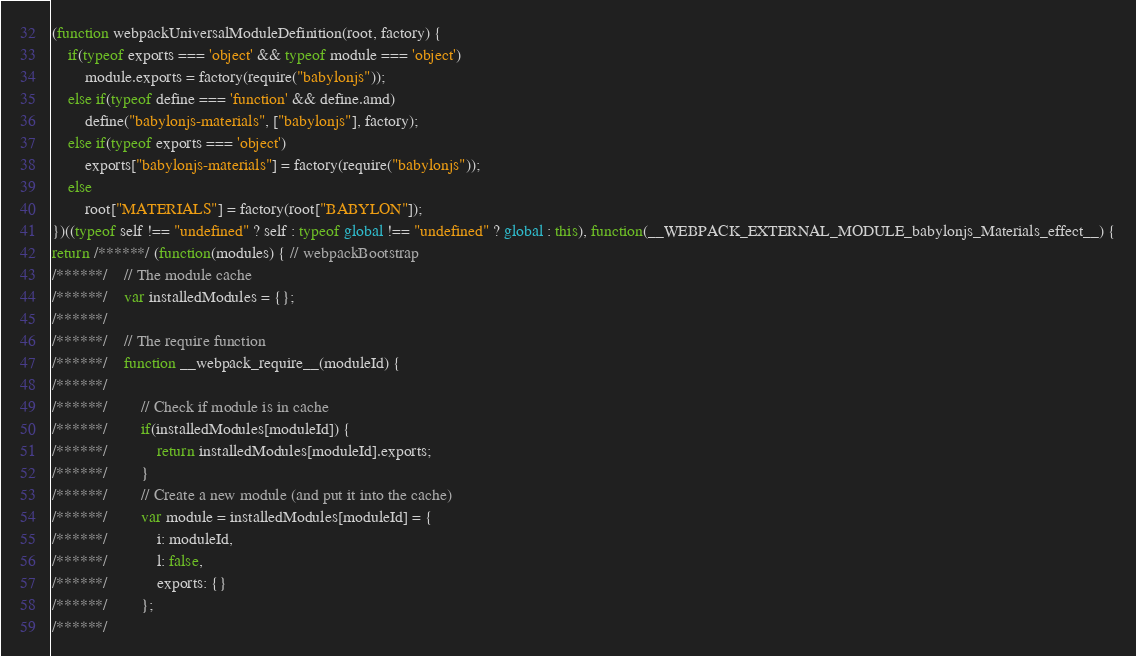<code> <loc_0><loc_0><loc_500><loc_500><_JavaScript_>(function webpackUniversalModuleDefinition(root, factory) {
	if(typeof exports === 'object' && typeof module === 'object')
		module.exports = factory(require("babylonjs"));
	else if(typeof define === 'function' && define.amd)
		define("babylonjs-materials", ["babylonjs"], factory);
	else if(typeof exports === 'object')
		exports["babylonjs-materials"] = factory(require("babylonjs"));
	else
		root["MATERIALS"] = factory(root["BABYLON"]);
})((typeof self !== "undefined" ? self : typeof global !== "undefined" ? global : this), function(__WEBPACK_EXTERNAL_MODULE_babylonjs_Materials_effect__) {
return /******/ (function(modules) { // webpackBootstrap
/******/ 	// The module cache
/******/ 	var installedModules = {};
/******/
/******/ 	// The require function
/******/ 	function __webpack_require__(moduleId) {
/******/
/******/ 		// Check if module is in cache
/******/ 		if(installedModules[moduleId]) {
/******/ 			return installedModules[moduleId].exports;
/******/ 		}
/******/ 		// Create a new module (and put it into the cache)
/******/ 		var module = installedModules[moduleId] = {
/******/ 			i: moduleId,
/******/ 			l: false,
/******/ 			exports: {}
/******/ 		};
/******/</code> 